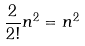Convert formula to latex. <formula><loc_0><loc_0><loc_500><loc_500>\frac { 2 } { 2 ! } n ^ { 2 } = n ^ { 2 }</formula> 